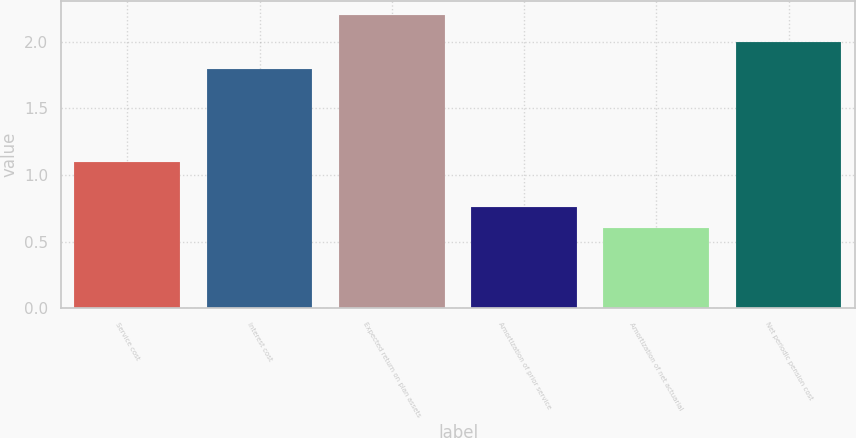Convert chart to OTSL. <chart><loc_0><loc_0><loc_500><loc_500><bar_chart><fcel>Service cost<fcel>Interest cost<fcel>Expected return on plan assets<fcel>Amortization of prior service<fcel>Amortization of net actuarial<fcel>Net periodic pension cost<nl><fcel>1.1<fcel>1.8<fcel>2.2<fcel>0.76<fcel>0.6<fcel>2<nl></chart> 